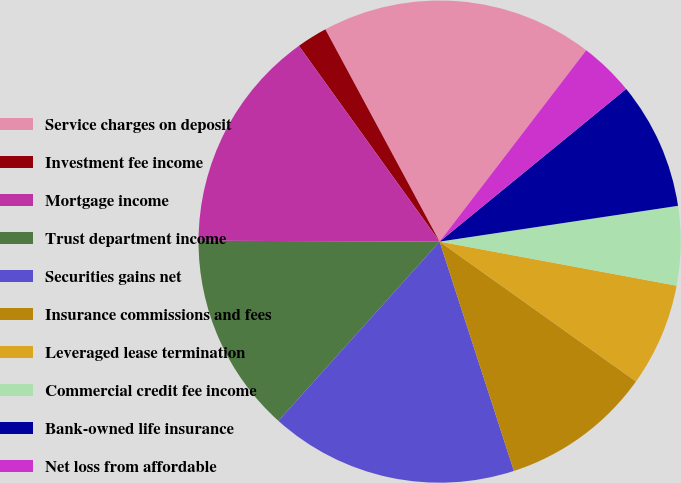Convert chart to OTSL. <chart><loc_0><loc_0><loc_500><loc_500><pie_chart><fcel>Service charges on deposit<fcel>Investment fee income<fcel>Mortgage income<fcel>Trust department income<fcel>Securities gains net<fcel>Insurance commissions and fees<fcel>Leveraged lease termination<fcel>Commercial credit fee income<fcel>Bank-owned life insurance<fcel>Net loss from affordable<nl><fcel>18.26%<fcel>2.06%<fcel>15.02%<fcel>13.4%<fcel>16.64%<fcel>10.16%<fcel>6.92%<fcel>5.3%<fcel>8.54%<fcel>3.68%<nl></chart> 